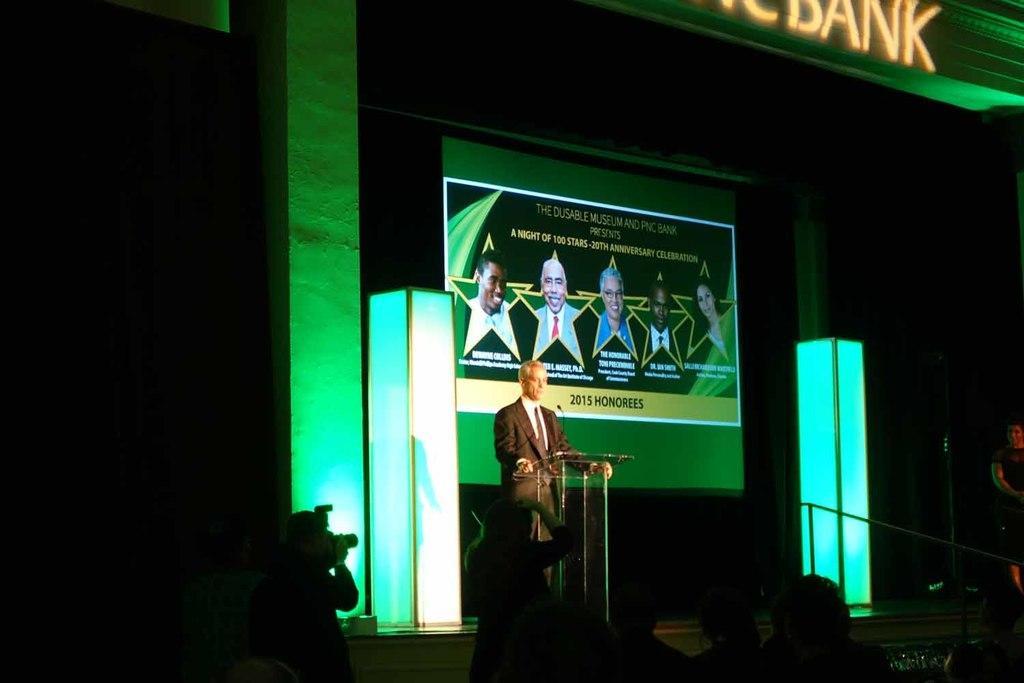Please provide a concise description of this image. A man is standing, this is microphone, there is screen with people on it, here there are people. 